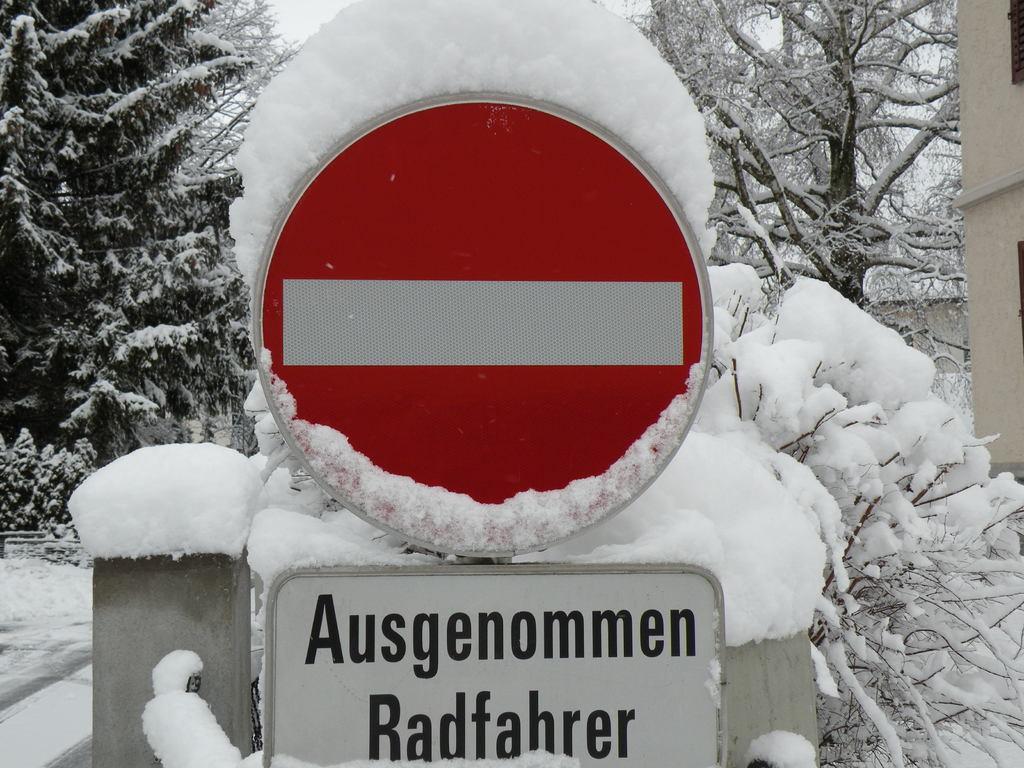In one or two sentences, can you explain what this image depicts? In this image there is a sign board. Below to it there is a board with text. Behind the board there is the snow. In the background there are trees. There is snow on the trees and on the ground. To the right there is a wall. 